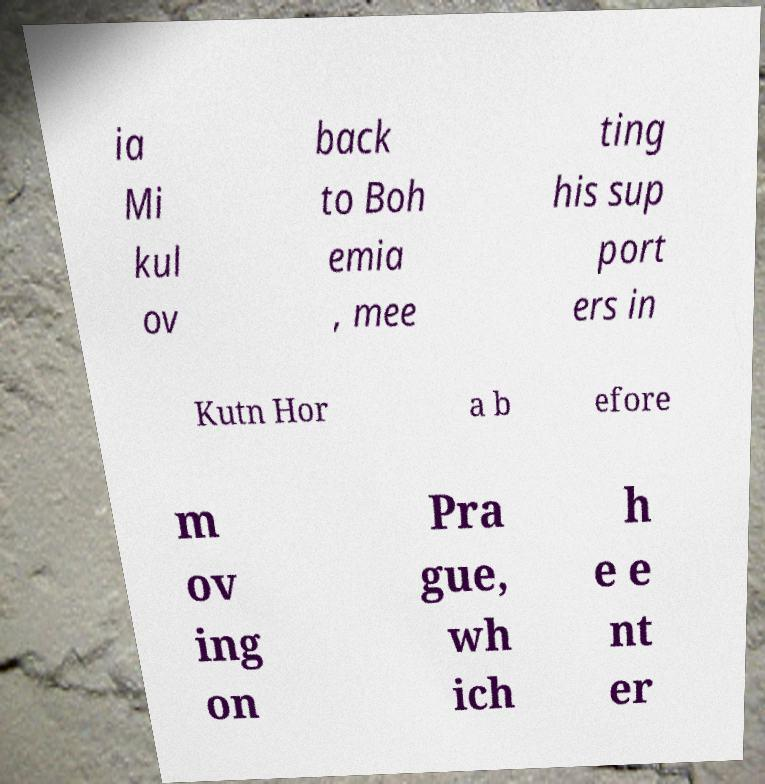What messages or text are displayed in this image? I need them in a readable, typed format. ia Mi kul ov back to Boh emia , mee ting his sup port ers in Kutn Hor a b efore m ov ing on Pra gue, wh ich h e e nt er 